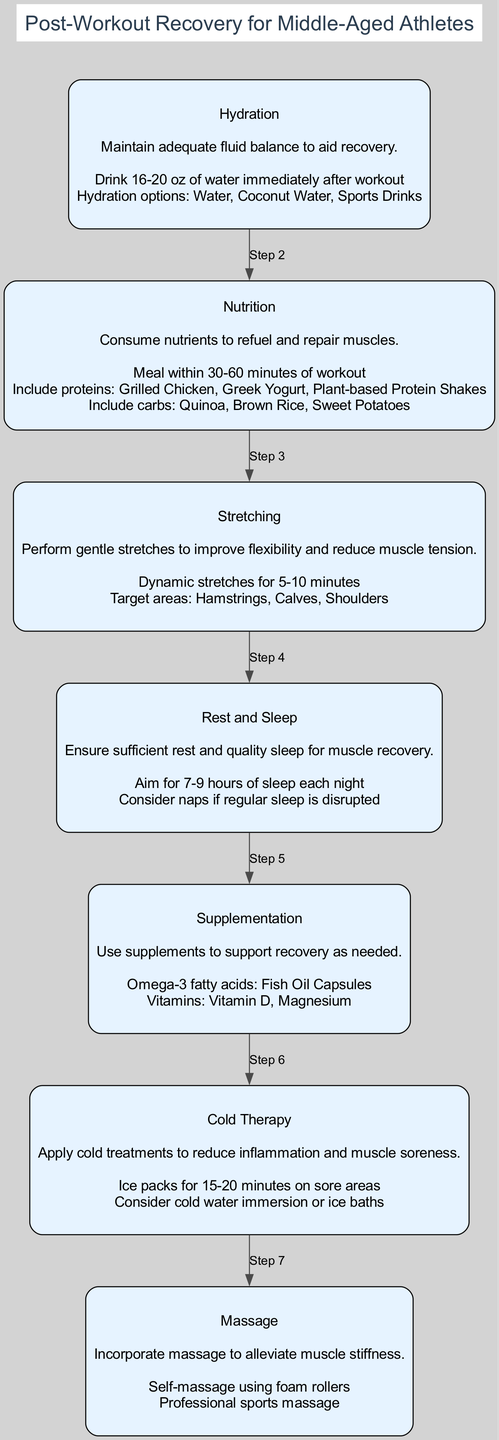What is the first step in the clinical pathway? The first step is Hydration, which is indicated at the top of the diagram as the initial action in the recovery process.
Answer: Hydration How many total steps are in the clinical pathway? There are six steps listed in the clinical pathway, each representing a different aspect of post-workout recovery.
Answer: 6 What action should be taken immediately after a workout? The diagram specifies that the action to take immediately after a workout is to drink 16-20 oz of water.
Answer: Drink 16-20 oz of water Which step includes recommendations for sleep duration? The Rest and Sleep step advises aiming for 7-9 hours of sleep each night for effective recovery.
Answer: Rest and Sleep What is the second action listed under Nutrition? The second action listed under Nutrition is to include carbs: Quinoa, Brown Rice, Sweet Potatoes as part of the post-workout meal.
Answer: Include carbs: Quinoa, Brown Rice, Sweet Potatoes What is the primary purpose of Cold Therapy in the pathway? Cold Therapy is aimed at reducing inflammation and muscle soreness, as indicated in the description of that step.
Answer: Reduce inflammation and muscle soreness What is the relationship between the Nutrition step and the Hydration step? The Nutrition step follows the Hydration step in the clinical pathway, indicating that both are important and sequential actions in recovery.
Answer: Nutrition follows Hydration Which step provides options for handling muscle stiffness? The Massage step incorporates self-massage using foam rollers and professional sports massage to alleviate muscle stiffness.
Answer: Massage What extra support does Supplementation offer in the recovery pathway? The Supplementation step suggests using Omega-3 fatty acids and vitamins like Vitamin D and Magnesium to support recovery as needed.
Answer: Omega-3 fatty acids, Vitamins: Vitamin D, Magnesium 